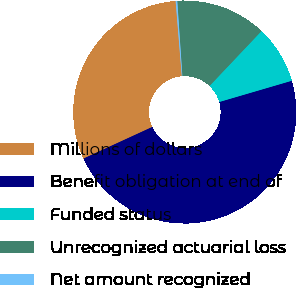Convert chart. <chart><loc_0><loc_0><loc_500><loc_500><pie_chart><fcel>Millions of dollars<fcel>Benefit obligation at end of<fcel>Funded status<fcel>Unrecognized actuarial loss<fcel>Net amount recognized<nl><fcel>30.55%<fcel>47.67%<fcel>8.4%<fcel>13.14%<fcel>0.23%<nl></chart> 